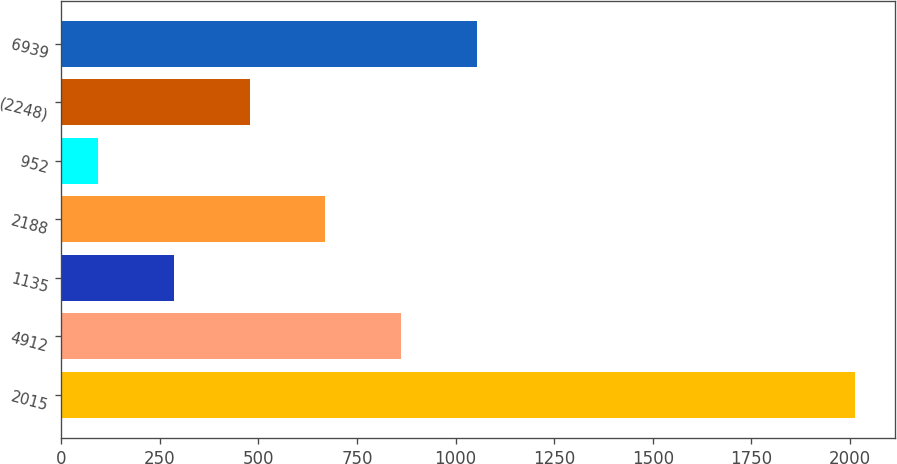<chart> <loc_0><loc_0><loc_500><loc_500><bar_chart><fcel>2015<fcel>4912<fcel>1135<fcel>2188<fcel>952<fcel>(2248)<fcel>6939<nl><fcel>2014<fcel>861.64<fcel>285.46<fcel>669.58<fcel>93.4<fcel>477.52<fcel>1053.7<nl></chart> 